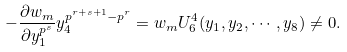Convert formula to latex. <formula><loc_0><loc_0><loc_500><loc_500>- \frac { \partial w _ { m } } { \partial y _ { 1 } ^ { p ^ { s } } } y _ { 4 } ^ { p ^ { r + s + 1 } - p ^ { r } } = w _ { m } U _ { 6 } ^ { 4 } ( y _ { 1 } , y _ { 2 } , \cdots , y _ { 8 } ) \neq 0 .</formula> 